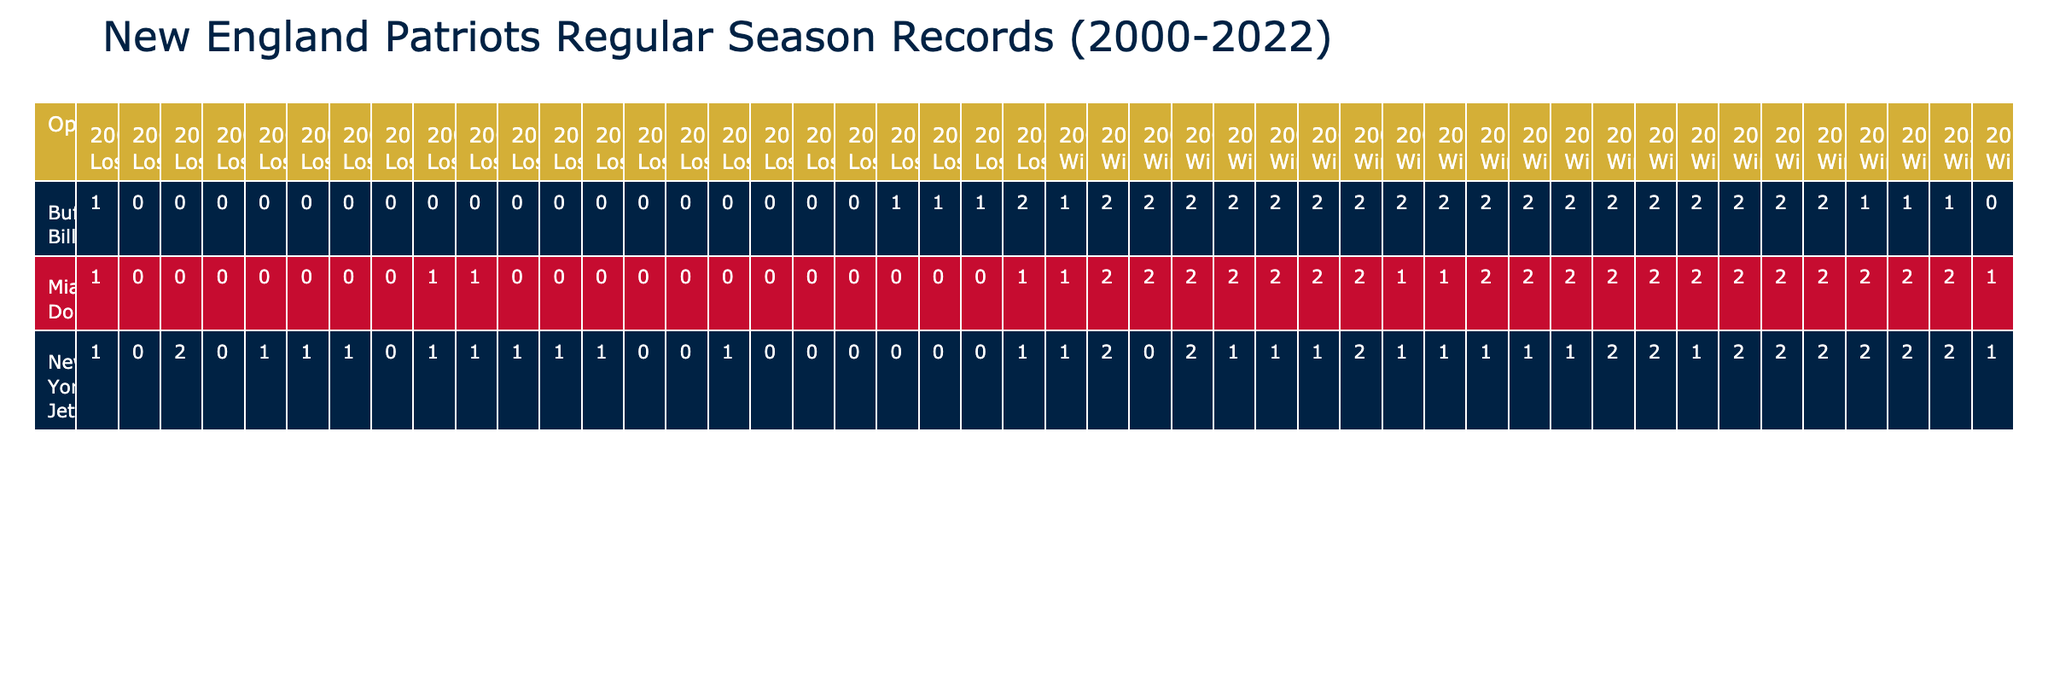What is the New England Patriots' total win record against the Miami Dolphins from 2000 to 2022? To find this, I will look for the column entries under the 'Wins' row for the Miami Dolphins across all seasons from 2000 to 2022. The wins are as follows: 1, 2, 2, 2, 2, 2, 2, 2, 2, 2, 2, 2, 2, 1, 2, 1, and 1. Adding these gives me a total of 27 wins.
Answer: 27 How many losses did the Patriots have against the New York Jets in total from 2000 to 2022? I will look for the 'Losses' values for the New York Jets for each season. The losses are as follows: 1, 0, 0, 1, 1, 1, 0, 0, 0, 0, 0, 0, 0, 0, 0, 0, and 2. Adding these values together results in a total of 5 losses.
Answer: 5 Was the win-loss record against the Buffalo Bills in 2021 a win or a loss for the Patriots? To answer this, I need to check the entry for the Buffalo Bills in the 2021 season. The record shows 1 win and 1 loss against them. Therefore, in 2021, the Patriots had a split record (1-1) against the Buffalo Bills, meaning it was neither a clear win nor a loss for that season.
Answer: No What is the average number of wins the Patriots had against the Buffalo Bills from 2000 to 2022? To find the average, I will sum the wins against Buffalo for all seasons: 1, 2, 2, 2, 2, 2, 2, 2, 2, 2, 2, 2, 2, 2, 2, 2, and 1. The total is 30 wins over 23 seasons. The average can be calculated as 30 divided by 23, which gives approximately 1.3.
Answer: 1.3 In which season did the Patriots lose the most games against the Miami Dolphins? I will examine the number of losses for the Miami Dolphins in each season. The losses are: 1, 0, 0, 0, 0, 0, 0, 1, 1, 1, 0, 0, 0, and 0. The maximum number of losses was 2 in the seasons of 2000 and 2022, indicating a tie for the most losses against the Dolphins.
Answer: 2000 and 2022 